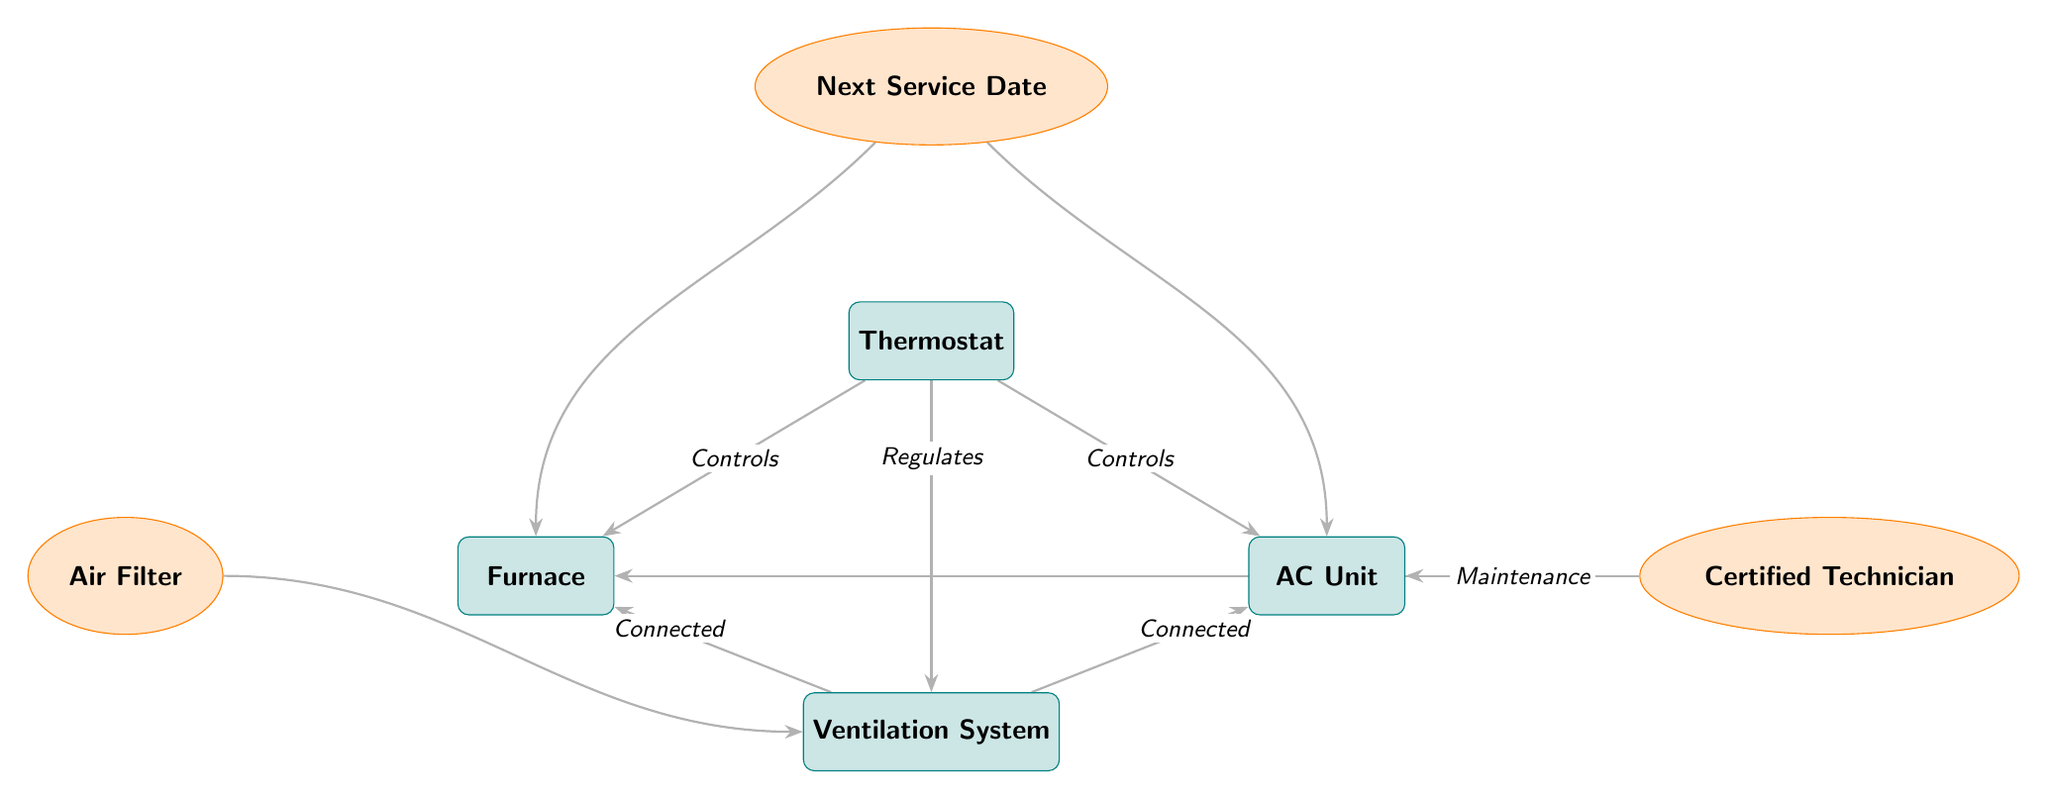What is the primary device that controls both the furnace and the AC unit? The diagram shows a direct connection labeled "Controls" from the Thermostat to both the Furnace and the AC Unit, indicating that the Thermostat is the primary control device for these units.
Answer: Thermostat How many maintenance elements are present in the diagram? The diagram includes three maintenance elements: Air Filter, Next Service Date, and Certified Technician. Counting these, we find there are three elements present.
Answer: 3 What connects the ventilation system to the furnace? The diagram indicates a connection labeled "Connected" from the Ventilation System to the Furnace, demonstrating the relationship between these two devices.
Answer: Connected What is the purpose of the certified technician in the HVAC system? The diagram shows a connection labeled "Maintenance" going from the Certified Technician to both the Furnace and the AC Unit, signifying that the technician is responsible for the maintenance of these systems.
Answer: Maintenance Which component integrates with the ventilation system? The diagram features an element labeled "Air Filter" that has a connection to the Ventilation System, indicating that the Air Filter integrates with this component of the HVAC system.
Answer: Air Filter What is indicated by the next service date in relation to the HVAC components? The Next Service Date has connections labeled "Check-up" going to both the Furnace and the AC Unit, which suggests that it is a reminder for scheduled check-ups for these components.
Answer: Check-up Which two components are controlled by the thermostat? The thermostat controls the Furnace and the AC Unit, which is clearly shown by direct connections labeled "Controls," indicating that both components are governed by the thermostat.
Answer: Furnace, AC Unit What is the relationship between the ventilation system and the AC unit? The diagram shows a connection labeled "Connected" which indicates that there is a direct relationship between the Ventilation System and the AC Unit, meaning they are interconnected in the HVAC setup.
Answer: Connected 